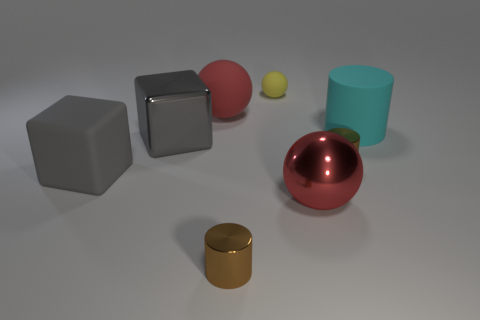Does the tiny metal thing behind the gray rubber cube have the same color as the tiny cylinder that is to the left of the small yellow rubber ball?
Your answer should be compact. Yes. There is a small brown cylinder behind the gray rubber cube in front of the tiny yellow sphere; what is it made of?
Offer a terse response. Metal. The rubber ball that is the same size as the matte cube is what color?
Offer a very short reply. Red. Do the large gray metal object and the large gray matte thing that is on the left side of the big metallic ball have the same shape?
Offer a terse response. Yes. There is a metal thing that is the same color as the rubber block; what shape is it?
Offer a terse response. Cube. What number of small shiny cylinders are behind the large gray thing that is behind the small brown shiny object to the right of the shiny sphere?
Make the answer very short. 0. What size is the gray cube that is behind the small cylinder behind the red metal thing?
Make the answer very short. Large. There is a red thing that is the same material as the cyan thing; what size is it?
Offer a terse response. Large. The matte thing that is both right of the large matte ball and in front of the red matte thing has what shape?
Give a very brief answer. Cylinder. Are there the same number of tiny objects that are in front of the small sphere and blue matte cubes?
Give a very brief answer. No. 